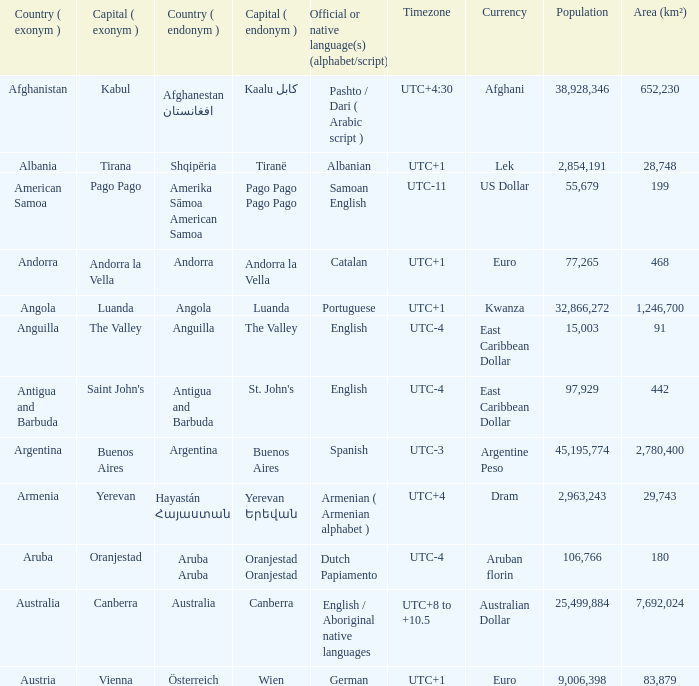Write the full table. {'header': ['Country ( exonym )', 'Capital ( exonym )', 'Country ( endonym )', 'Capital ( endonym )', 'Official or native language(s) (alphabet/script)', 'Timezone', 'Currency', 'Population', 'Area (km²)'], 'rows': [['Afghanistan', 'Kabul', 'Afghanestan افغانستان', 'Kaalu كابل', 'Pashto / Dari ( Arabic script )', 'UTC+4:30', 'Afghani', '38,928,346', '652,230'], ['Albania', 'Tirana', 'Shqipëria', 'Tiranë', 'Albanian', 'UTC+1', 'Lek', '2,854,191', '28,748'], ['American Samoa', 'Pago Pago', 'Amerika Sāmoa American Samoa', 'Pago Pago Pago Pago', 'Samoan English', 'UTC-11', 'US Dollar', '55,679', '199'], ['Andorra', 'Andorra la Vella', 'Andorra', 'Andorra la Vella', 'Catalan', 'UTC+1', 'Euro', '77,265', '468'], ['Angola', 'Luanda', 'Angola', 'Luanda', 'Portuguese', 'UTC+1', 'Kwanza', '32,866,272', '1,246,700'], ['Anguilla', 'The Valley', 'Anguilla', 'The Valley', 'English', 'UTC-4', 'East Caribbean Dollar', '15,003', '91'], ['Antigua and Barbuda', "Saint John's", 'Antigua and Barbuda', "St. John's", 'English', 'UTC-4', 'East Caribbean Dollar', '97,929', '442'], ['Argentina', 'Buenos Aires', 'Argentina', 'Buenos Aires', 'Spanish', 'UTC-3', 'Argentine Peso', '45,195,774', '2,780,400'], ['Armenia', 'Yerevan', 'Hayastán Հայաստան', 'Yerevan Երեվան', 'Armenian ( Armenian alphabet )', 'UTC+4', 'Dram', '2,963,243', '29,743'], ['Aruba', 'Oranjestad', 'Aruba Aruba', 'Oranjestad Oranjestad', 'Dutch Papiamento', 'UTC-4', 'Aruban florin', '106,766', '180'], ['Australia', 'Canberra', 'Australia', 'Canberra', 'English / Aboriginal native languages', 'UTC+8 to +10.5', 'Australian Dollar', '25,499,884', '7,692,024'], ['Austria', 'Vienna', 'Österreich', 'Wien', 'German', 'UTC+1', 'Euro', '9,006,398', '83,879']]} What is the English name given to the city of St. John's? Saint John's. 